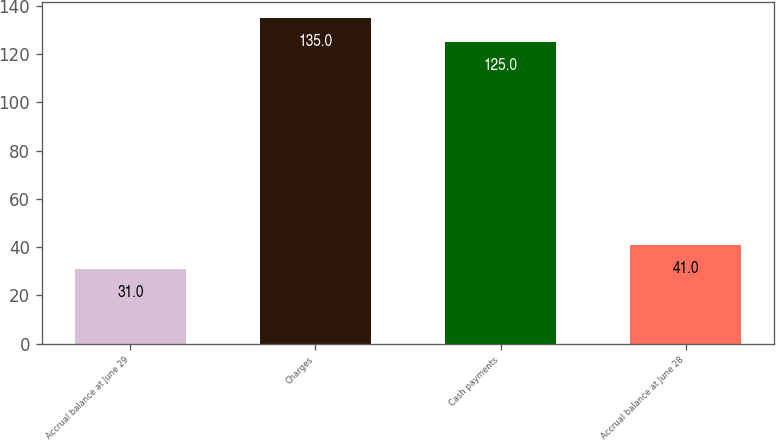<chart> <loc_0><loc_0><loc_500><loc_500><bar_chart><fcel>Accrual balance at June 29<fcel>Charges<fcel>Cash payments<fcel>Accrual balance at June 28<nl><fcel>31<fcel>135<fcel>125<fcel>41<nl></chart> 